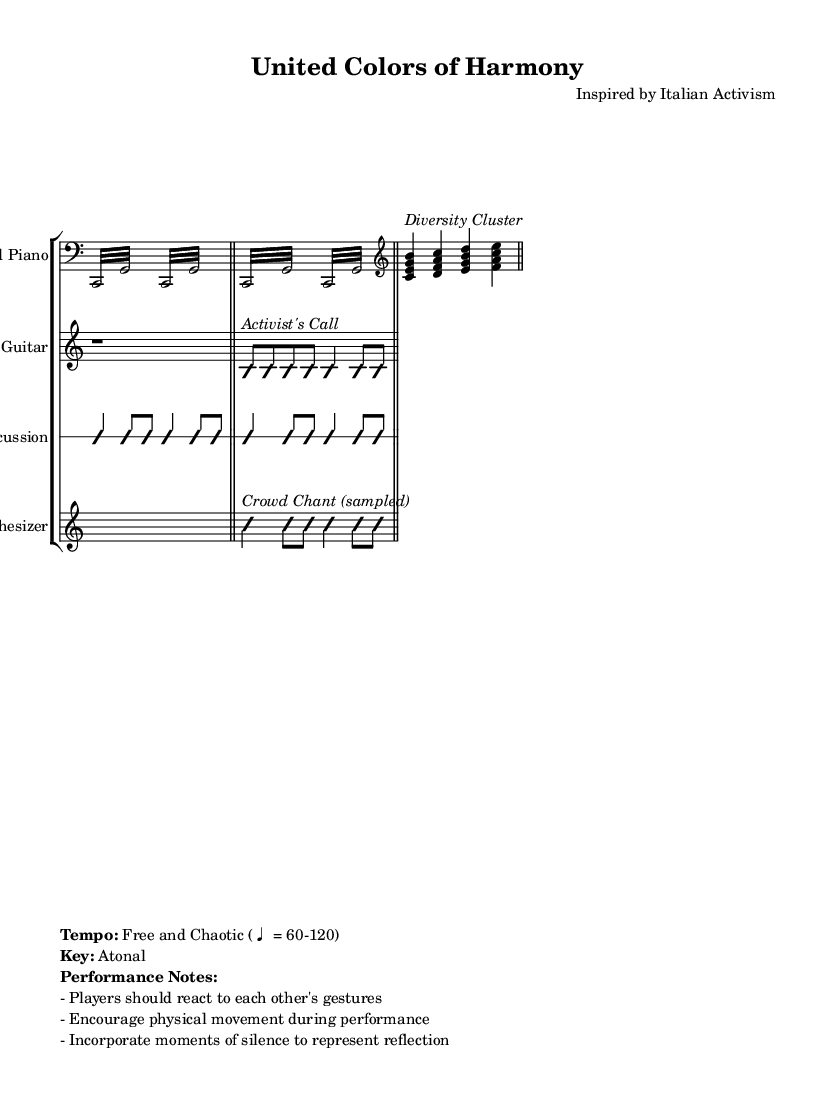What is the time signature of this music? The time signature is 4/4, as indicated at the beginning of the score.
Answer: 4/4 What instrument is the first staff representing? The first staff represents a Prepared Piano, stated in the instrument name.
Answer: Prepared Piano What is the performance tempo associated with this piece? The performance tempo is described as "Free and Chaotic" in the performance notes, indicating a flexible tempo range.
Answer: Free and Chaotic (♩ = 60-120) How many repeated segments are there for the Prepared Piano section? The Prepared Piano section has four repeated segments, each indicated by the repeat sign.
Answer: 4 What is the name of the section that includes the synthesizer? The synthesizer section includes a "Crowd Chant (sampled)" indicated by the markup in the music.
Answer: Crowd Chant (sampled) In which measure does the improvisation for the Electric Guitar begin? The improvisation for the Electric Guitar starts in the second measure after the first bar.
Answer: 1st measure after the bar What is the significance of the "Diversity Cluster" within the piece? The "Diversity Cluster" signifies a grouping of notes that represent different musical ideas, emphasizing diversity through harmonies.
Answer: Diversity Cluster 